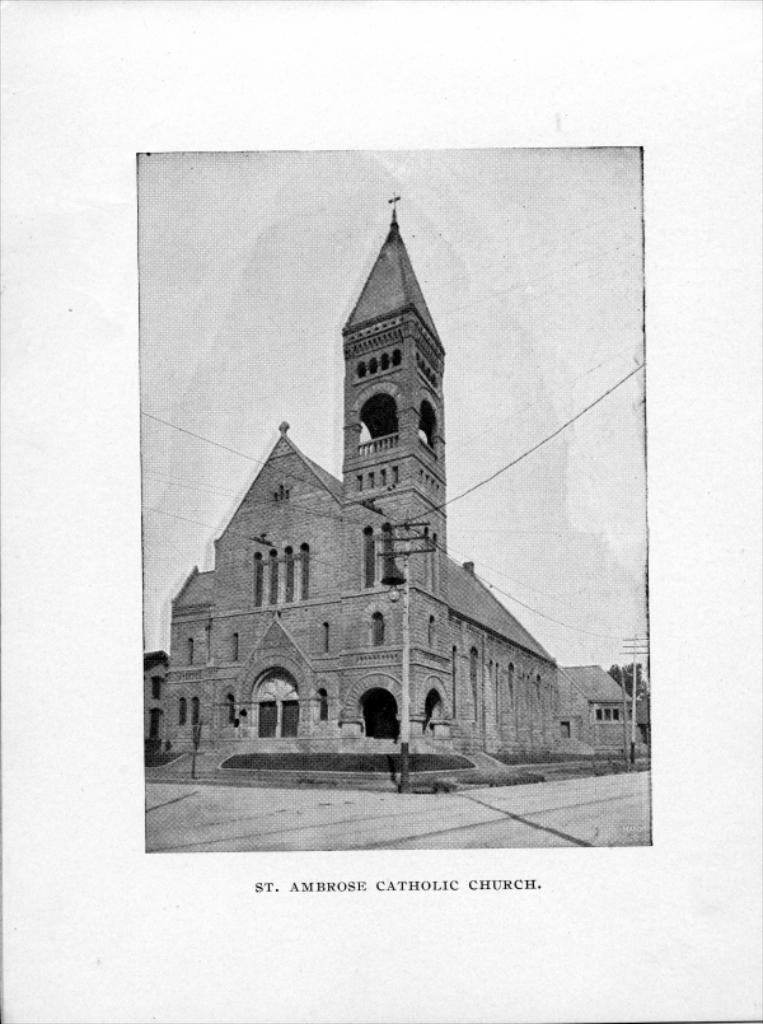What is the color scheme of the image? The image is black and white. What can be seen in the image besides the color scheme? There is a building and the sky visible in the image. Where is the text or writing located in the image? The text or writing is at the bottom of the image. What type of waste is being disposed of in the image? There is no waste present in the image; it features a black and white image of a building with text at the bottom and the sky visible at the top. How many stitches are visible on the building in the image? There are no stitches visible on the building in the image; it is a photograph or illustration of a building. 